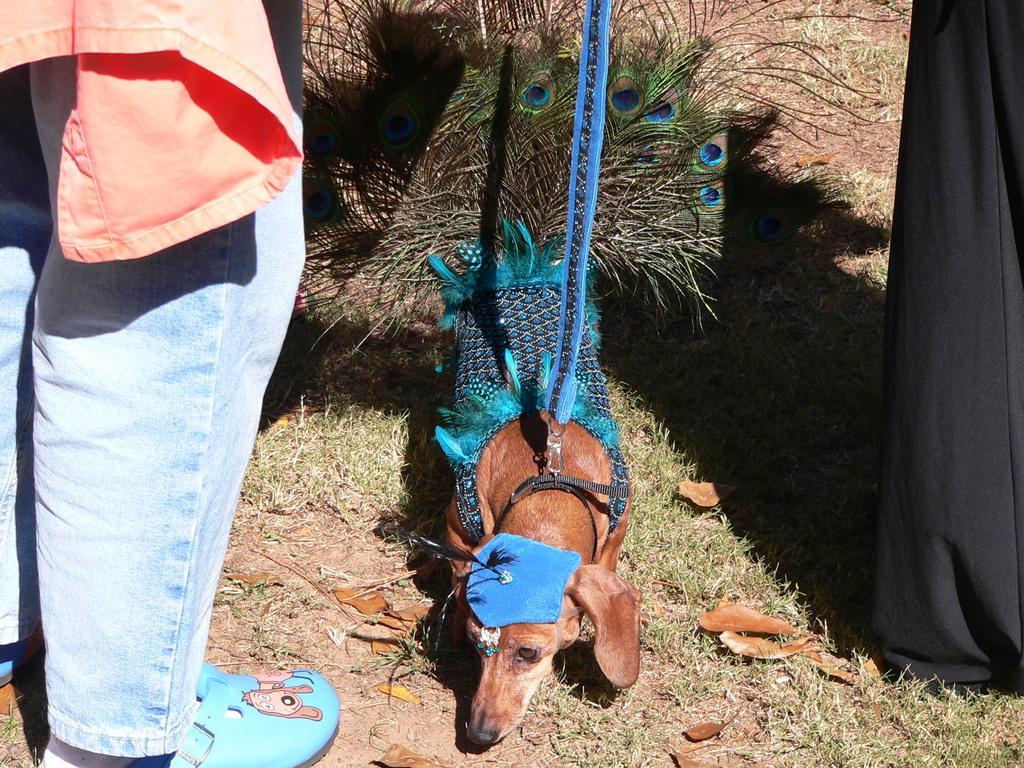How would you summarize this image in a sentence or two? There is a dog it is tied with a blue chain and a person is holding the chain behind the dog there are peacock feathers and on the left side another person is standing and the person is wearing blue color footwear, the dog is laying on the grass, a huge sunlight is focusing on the dog. 